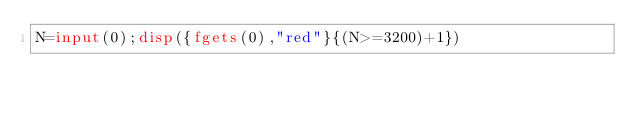Convert code to text. <code><loc_0><loc_0><loc_500><loc_500><_Octave_>N=input(0);disp({fgets(0),"red"}{(N>=3200)+1})</code> 